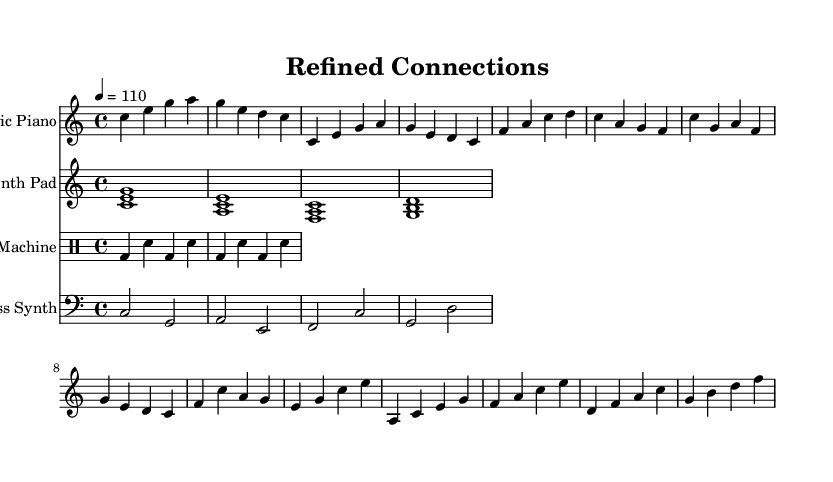what is the key signature of this music? The key signature is C major, which has no sharps or flats.
Answer: C major what is the time signature of this piece? The time signature is indicated at the beginning of the score as 4/4, meaning there are four beats per measure.
Answer: 4/4 what is the tempo marking for this piece? The tempo is specified as quarter note equals 110 beats per minute, indicating the speed of the piece.
Answer: 110 what instruments are included in this score? The score includes an Electric Piano, Synth Pad, Drum Machine, and Bass Synth, which are all indicated by their respective staves.
Answer: Electric Piano, Synth Pad, Drum Machine, Bass Synth which section of the music has the chord progression C, E, G, A? This chord progression occurs in the introduction and also in the verse section, indicating the tonal foundation of the piece.
Answer: Intro and Verse how many measures are in the Chorus section? The Chorus section is composed of four measures, as indicated by the grouping of notes.
Answer: Four measures which instrument plays the bass line? The bass line is played by the Bass Synth, which is written on the bass clef staff.
Answer: Bass Synth 